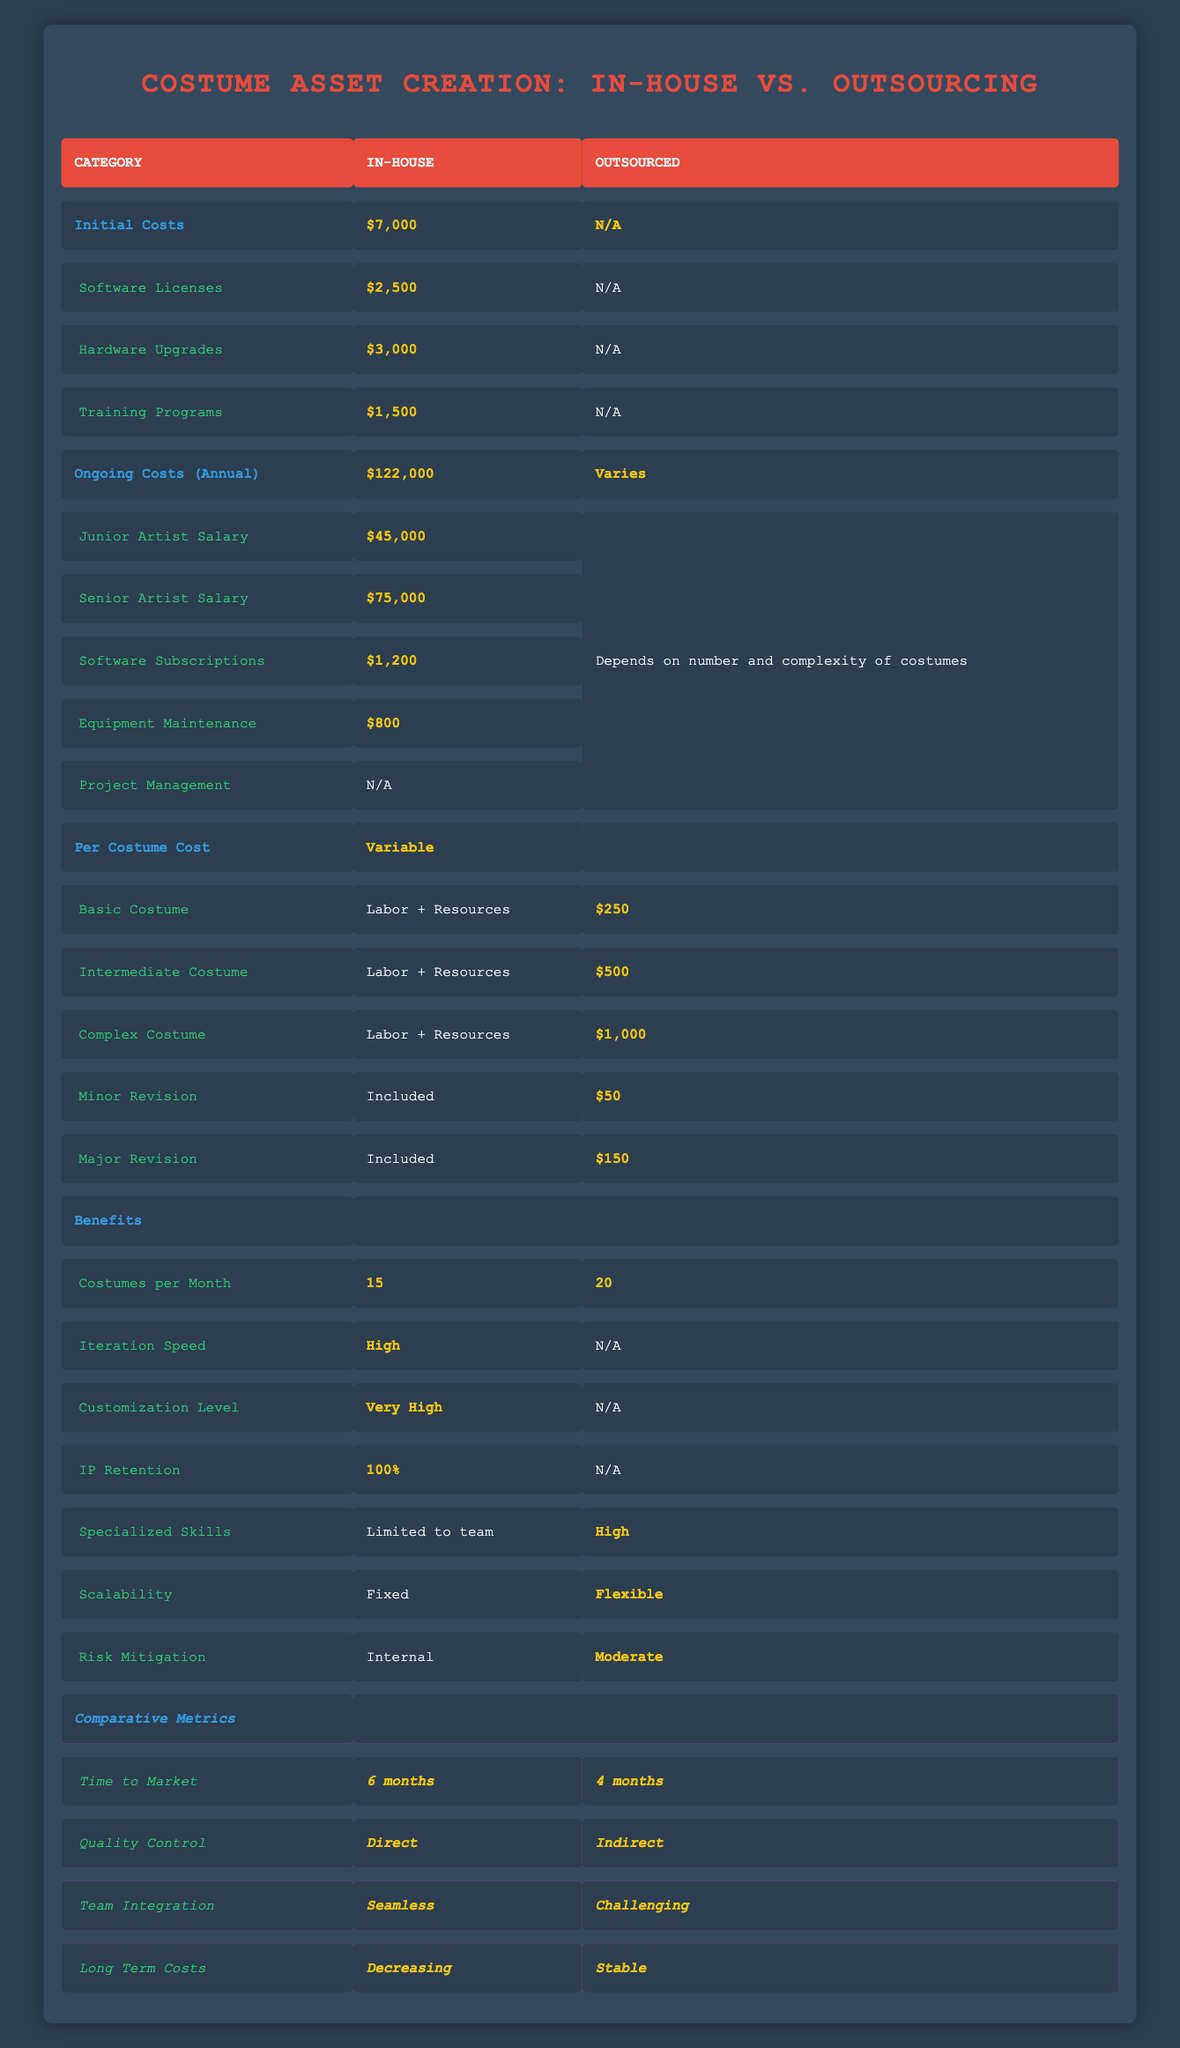What are the initial costs for in-house costume creation? The table lists the initial costs under the "Initial Costs" category for in-house costume creation, which sum up to 7000.
Answer: 7000 How much does a complex costume cost if outsourced? In the "Outsourced" category under "Per Costume Cost," the value for a complex costume is given as 1000.
Answer: 1000 Is the quality control for outsourced costume creation direct? The table indicates that for outsourced costume creation, the quality control is stated as "Indirect," which is a clear indication that the quality control is not direct.
Answer: No What is the difference in the time to market between in-house and outsourced costume creation? The table states that in-house time to market is 6 months and outsourced is 4 months. The difference is calculated as 6 - 4 = 2 months.
Answer: 2 months How many costumes can be produced per month in-house compared to outsourcing? The table shows 15 costumes per month for in-house and 20 for outsourcing. To find the difference, subtract 15 from 20, resulting in 5 more costumes produced through outsourcing.
Answer: 5 more costumes What is the total ongoing cost for in-house costume creation annually? In the table, the total ongoing costs for in-house are listed as 122,000 under the "Ongoing Costs (Annual)" category.
Answer: 122000 Does in-house costume creation allow for higher customization levels compared to outsourced? The table indicates that in-house costume creation has a "Very High" customization level, while this information isn't provided for outsourced, indicating that in-house allows for potentially higher customization.
Answer: Yes Which option, in-house or outsourcing, has lower long-term costs according to the table? The comparative metrics state that long-term costs for in-house are "Decreasing," while they are "Stable" for outsourced. Hence, in-house is the more fluctuating option in terms of costs.
Answer: In-house What are the benefits of outsourcing in terms of scalability and risk mitigation? From the benefits section, outsourcing has "Flexible" scalability and "Moderate" risk mitigation, revealing advantages in adjusting resources and managing risks effectively.
Answer: Flexible and Moderate 